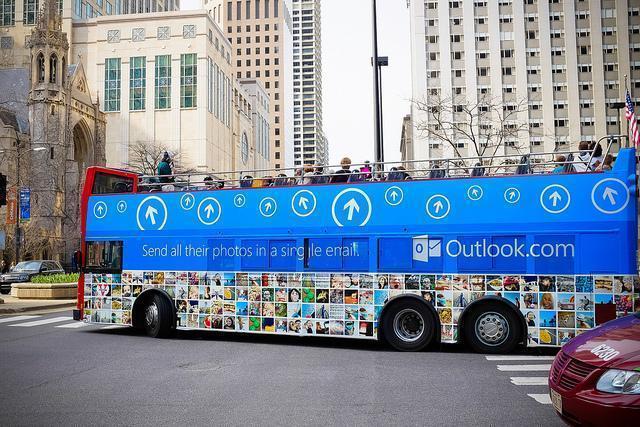What country is this street found in?
Indicate the correct response by choosing from the four available options to answer the question.
Options: France, australia, united states, britain. United states. 